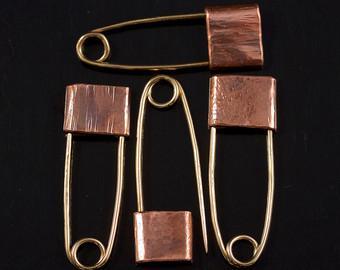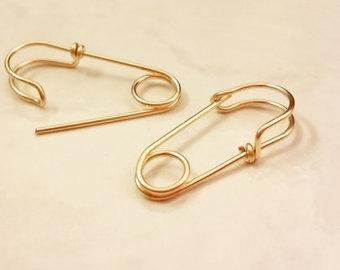The first image is the image on the left, the second image is the image on the right. Given the left and right images, does the statement "There is one open safety pin." hold true? Answer yes or no. Yes. 